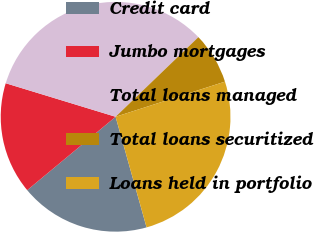Convert chart to OTSL. <chart><loc_0><loc_0><loc_500><loc_500><pie_chart><fcel>Credit card<fcel>Jumbo mortgages<fcel>Total loans managed<fcel>Total loans securitized<fcel>Loans held in portfolio<nl><fcel>18.32%<fcel>15.74%<fcel>33.1%<fcel>7.24%<fcel>25.6%<nl></chart> 